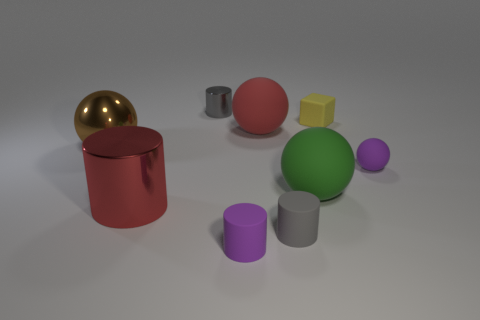Add 1 big red spheres. How many objects exist? 10 Subtract all tiny purple rubber spheres. How many spheres are left? 3 Subtract all red cylinders. How many cylinders are left? 3 Subtract 2 cylinders. How many cylinders are left? 2 Subtract 1 red cylinders. How many objects are left? 8 Subtract all balls. How many objects are left? 5 Subtract all yellow balls. Subtract all yellow cylinders. How many balls are left? 4 Subtract all red balls. How many gray cylinders are left? 2 Subtract all tiny green matte blocks. Subtract all big brown shiny spheres. How many objects are left? 8 Add 5 rubber cylinders. How many rubber cylinders are left? 7 